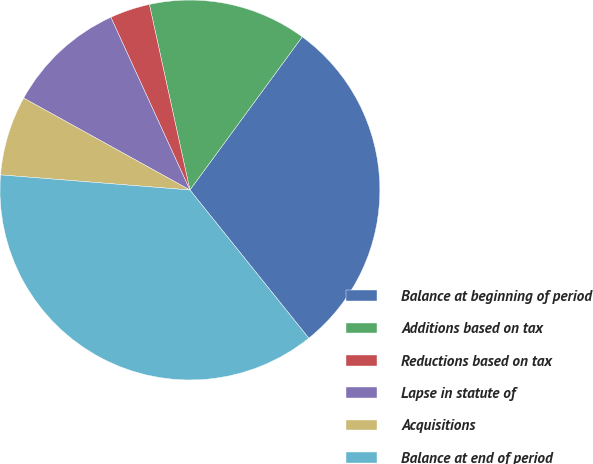<chart> <loc_0><loc_0><loc_500><loc_500><pie_chart><fcel>Balance at beginning of period<fcel>Additions based on tax<fcel>Reductions based on tax<fcel>Lapse in statute of<fcel>Acquisitions<fcel>Balance at end of period<nl><fcel>29.17%<fcel>13.49%<fcel>3.41%<fcel>10.13%<fcel>6.77%<fcel>37.03%<nl></chart> 